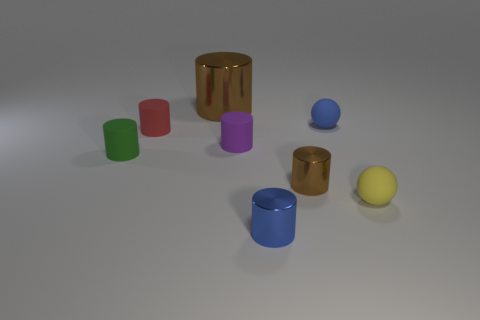How many objects are there in total, and could you describe their arrangement? There are a total of eight objects, with a variety of colors including green, red, purple, blue, gold, and yellow. They are arranged seemingly at random on a flat surface, with some objects standing upright and others lying on their sides, creating a visually interesting and non-uniform display. 